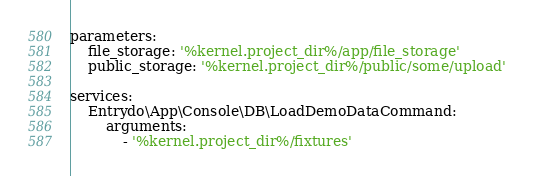<code> <loc_0><loc_0><loc_500><loc_500><_YAML_>parameters:
    file_storage: '%kernel.project_dir%/app/file_storage'
    public_storage: '%kernel.project_dir%/public/some/upload'

services:
    Entrydo\App\Console\DB\LoadDemoDataCommand:
        arguments:
            - '%kernel.project_dir%/fixtures'
</code> 